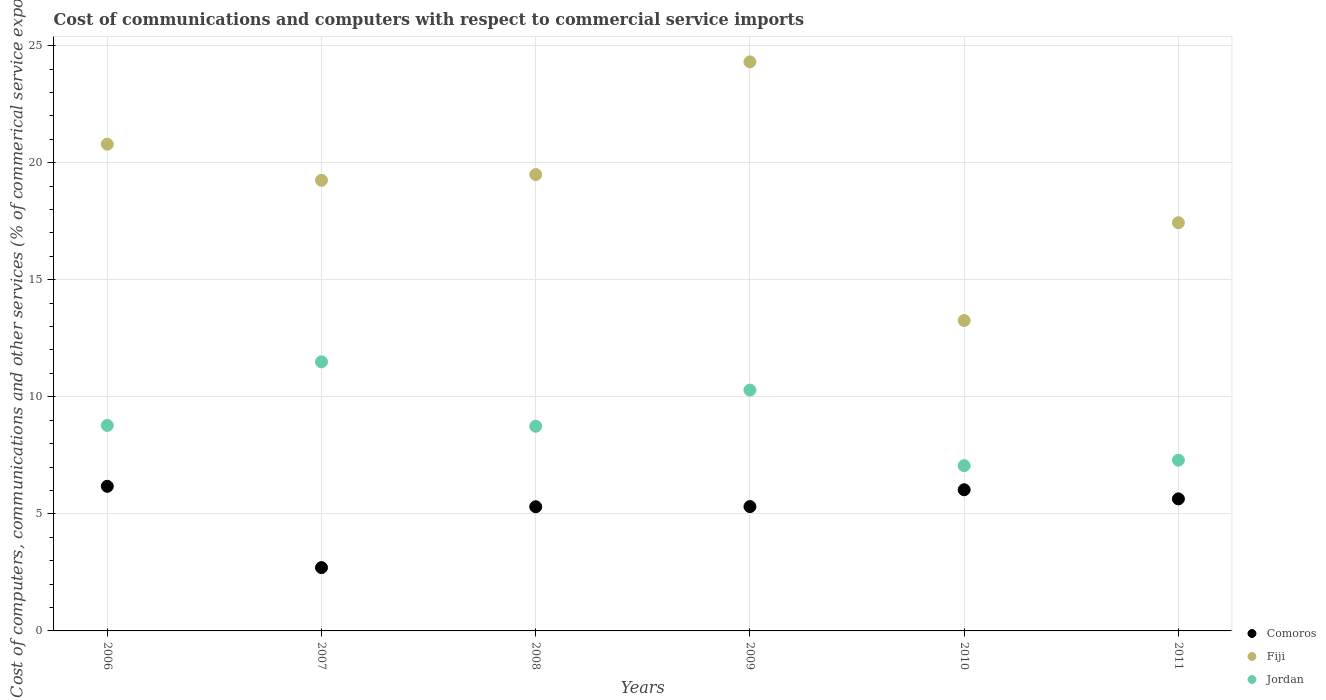How many different coloured dotlines are there?
Provide a succinct answer. 3. What is the cost of communications and computers in Comoros in 2010?
Provide a short and direct response. 6.03. Across all years, what is the maximum cost of communications and computers in Comoros?
Your answer should be compact. 6.18. Across all years, what is the minimum cost of communications and computers in Comoros?
Your answer should be very brief. 2.71. In which year was the cost of communications and computers in Fiji maximum?
Your response must be concise. 2009. In which year was the cost of communications and computers in Comoros minimum?
Make the answer very short. 2007. What is the total cost of communications and computers in Comoros in the graph?
Your response must be concise. 31.17. What is the difference between the cost of communications and computers in Fiji in 2008 and that in 2011?
Ensure brevity in your answer.  2.06. What is the difference between the cost of communications and computers in Jordan in 2011 and the cost of communications and computers in Fiji in 2008?
Give a very brief answer. -12.2. What is the average cost of communications and computers in Fiji per year?
Provide a short and direct response. 19.09. In the year 2007, what is the difference between the cost of communications and computers in Comoros and cost of communications and computers in Fiji?
Ensure brevity in your answer.  -16.54. In how many years, is the cost of communications and computers in Comoros greater than 5 %?
Offer a terse response. 5. What is the ratio of the cost of communications and computers in Comoros in 2007 to that in 2010?
Your answer should be compact. 0.45. Is the cost of communications and computers in Comoros in 2007 less than that in 2009?
Offer a very short reply. Yes. What is the difference between the highest and the second highest cost of communications and computers in Jordan?
Provide a succinct answer. 1.21. What is the difference between the highest and the lowest cost of communications and computers in Fiji?
Ensure brevity in your answer.  11.05. Is the sum of the cost of communications and computers in Jordan in 2008 and 2010 greater than the maximum cost of communications and computers in Comoros across all years?
Ensure brevity in your answer.  Yes. Is it the case that in every year, the sum of the cost of communications and computers in Comoros and cost of communications and computers in Fiji  is greater than the cost of communications and computers in Jordan?
Offer a terse response. Yes. Is the cost of communications and computers in Jordan strictly greater than the cost of communications and computers in Comoros over the years?
Offer a very short reply. Yes. How many dotlines are there?
Give a very brief answer. 3. Are the values on the major ticks of Y-axis written in scientific E-notation?
Offer a terse response. No. Where does the legend appear in the graph?
Ensure brevity in your answer.  Bottom right. What is the title of the graph?
Your answer should be very brief. Cost of communications and computers with respect to commercial service imports. Does "Tuvalu" appear as one of the legend labels in the graph?
Give a very brief answer. No. What is the label or title of the X-axis?
Keep it short and to the point. Years. What is the label or title of the Y-axis?
Keep it short and to the point. Cost of computers, communications and other services (% of commerical service exports). What is the Cost of computers, communications and other services (% of commerical service exports) in Comoros in 2006?
Keep it short and to the point. 6.18. What is the Cost of computers, communications and other services (% of commerical service exports) of Fiji in 2006?
Your answer should be compact. 20.79. What is the Cost of computers, communications and other services (% of commerical service exports) in Jordan in 2006?
Ensure brevity in your answer.  8.78. What is the Cost of computers, communications and other services (% of commerical service exports) of Comoros in 2007?
Provide a succinct answer. 2.71. What is the Cost of computers, communications and other services (% of commerical service exports) in Fiji in 2007?
Offer a very short reply. 19.25. What is the Cost of computers, communications and other services (% of commerical service exports) of Jordan in 2007?
Provide a short and direct response. 11.49. What is the Cost of computers, communications and other services (% of commerical service exports) in Comoros in 2008?
Your answer should be compact. 5.3. What is the Cost of computers, communications and other services (% of commerical service exports) in Fiji in 2008?
Offer a very short reply. 19.49. What is the Cost of computers, communications and other services (% of commerical service exports) of Jordan in 2008?
Give a very brief answer. 8.74. What is the Cost of computers, communications and other services (% of commerical service exports) in Comoros in 2009?
Your response must be concise. 5.31. What is the Cost of computers, communications and other services (% of commerical service exports) in Fiji in 2009?
Make the answer very short. 24.31. What is the Cost of computers, communications and other services (% of commerical service exports) in Jordan in 2009?
Provide a succinct answer. 10.29. What is the Cost of computers, communications and other services (% of commerical service exports) in Comoros in 2010?
Keep it short and to the point. 6.03. What is the Cost of computers, communications and other services (% of commerical service exports) of Fiji in 2010?
Offer a very short reply. 13.26. What is the Cost of computers, communications and other services (% of commerical service exports) in Jordan in 2010?
Provide a short and direct response. 7.06. What is the Cost of computers, communications and other services (% of commerical service exports) of Comoros in 2011?
Your answer should be compact. 5.64. What is the Cost of computers, communications and other services (% of commerical service exports) in Fiji in 2011?
Provide a succinct answer. 17.43. What is the Cost of computers, communications and other services (% of commerical service exports) of Jordan in 2011?
Offer a very short reply. 7.29. Across all years, what is the maximum Cost of computers, communications and other services (% of commerical service exports) in Comoros?
Give a very brief answer. 6.18. Across all years, what is the maximum Cost of computers, communications and other services (% of commerical service exports) in Fiji?
Your answer should be compact. 24.31. Across all years, what is the maximum Cost of computers, communications and other services (% of commerical service exports) in Jordan?
Your answer should be very brief. 11.49. Across all years, what is the minimum Cost of computers, communications and other services (% of commerical service exports) in Comoros?
Offer a very short reply. 2.71. Across all years, what is the minimum Cost of computers, communications and other services (% of commerical service exports) in Fiji?
Keep it short and to the point. 13.26. Across all years, what is the minimum Cost of computers, communications and other services (% of commerical service exports) in Jordan?
Your answer should be very brief. 7.06. What is the total Cost of computers, communications and other services (% of commerical service exports) of Comoros in the graph?
Make the answer very short. 31.17. What is the total Cost of computers, communications and other services (% of commerical service exports) in Fiji in the graph?
Your answer should be compact. 114.53. What is the total Cost of computers, communications and other services (% of commerical service exports) in Jordan in the graph?
Provide a succinct answer. 53.65. What is the difference between the Cost of computers, communications and other services (% of commerical service exports) of Comoros in 2006 and that in 2007?
Your answer should be compact. 3.47. What is the difference between the Cost of computers, communications and other services (% of commerical service exports) in Fiji in 2006 and that in 2007?
Offer a terse response. 1.54. What is the difference between the Cost of computers, communications and other services (% of commerical service exports) of Jordan in 2006 and that in 2007?
Provide a short and direct response. -2.72. What is the difference between the Cost of computers, communications and other services (% of commerical service exports) in Comoros in 2006 and that in 2008?
Your answer should be very brief. 0.87. What is the difference between the Cost of computers, communications and other services (% of commerical service exports) of Fiji in 2006 and that in 2008?
Keep it short and to the point. 1.3. What is the difference between the Cost of computers, communications and other services (% of commerical service exports) in Jordan in 2006 and that in 2008?
Provide a succinct answer. 0.03. What is the difference between the Cost of computers, communications and other services (% of commerical service exports) in Comoros in 2006 and that in 2009?
Ensure brevity in your answer.  0.87. What is the difference between the Cost of computers, communications and other services (% of commerical service exports) in Fiji in 2006 and that in 2009?
Make the answer very short. -3.52. What is the difference between the Cost of computers, communications and other services (% of commerical service exports) in Jordan in 2006 and that in 2009?
Keep it short and to the point. -1.51. What is the difference between the Cost of computers, communications and other services (% of commerical service exports) of Comoros in 2006 and that in 2010?
Keep it short and to the point. 0.15. What is the difference between the Cost of computers, communications and other services (% of commerical service exports) of Fiji in 2006 and that in 2010?
Your answer should be very brief. 7.53. What is the difference between the Cost of computers, communications and other services (% of commerical service exports) of Jordan in 2006 and that in 2010?
Offer a terse response. 1.72. What is the difference between the Cost of computers, communications and other services (% of commerical service exports) of Comoros in 2006 and that in 2011?
Your answer should be compact. 0.54. What is the difference between the Cost of computers, communications and other services (% of commerical service exports) in Fiji in 2006 and that in 2011?
Offer a terse response. 3.35. What is the difference between the Cost of computers, communications and other services (% of commerical service exports) of Jordan in 2006 and that in 2011?
Offer a very short reply. 1.48. What is the difference between the Cost of computers, communications and other services (% of commerical service exports) in Comoros in 2007 and that in 2008?
Your answer should be compact. -2.6. What is the difference between the Cost of computers, communications and other services (% of commerical service exports) in Fiji in 2007 and that in 2008?
Offer a terse response. -0.24. What is the difference between the Cost of computers, communications and other services (% of commerical service exports) in Jordan in 2007 and that in 2008?
Ensure brevity in your answer.  2.75. What is the difference between the Cost of computers, communications and other services (% of commerical service exports) in Comoros in 2007 and that in 2009?
Your response must be concise. -2.6. What is the difference between the Cost of computers, communications and other services (% of commerical service exports) in Fiji in 2007 and that in 2009?
Your answer should be very brief. -5.06. What is the difference between the Cost of computers, communications and other services (% of commerical service exports) of Jordan in 2007 and that in 2009?
Provide a succinct answer. 1.21. What is the difference between the Cost of computers, communications and other services (% of commerical service exports) of Comoros in 2007 and that in 2010?
Provide a short and direct response. -3.32. What is the difference between the Cost of computers, communications and other services (% of commerical service exports) in Fiji in 2007 and that in 2010?
Your answer should be compact. 5.99. What is the difference between the Cost of computers, communications and other services (% of commerical service exports) in Jordan in 2007 and that in 2010?
Your answer should be very brief. 4.44. What is the difference between the Cost of computers, communications and other services (% of commerical service exports) in Comoros in 2007 and that in 2011?
Your answer should be compact. -2.93. What is the difference between the Cost of computers, communications and other services (% of commerical service exports) in Fiji in 2007 and that in 2011?
Make the answer very short. 1.81. What is the difference between the Cost of computers, communications and other services (% of commerical service exports) in Jordan in 2007 and that in 2011?
Provide a succinct answer. 4.2. What is the difference between the Cost of computers, communications and other services (% of commerical service exports) in Comoros in 2008 and that in 2009?
Offer a very short reply. -0.01. What is the difference between the Cost of computers, communications and other services (% of commerical service exports) in Fiji in 2008 and that in 2009?
Provide a short and direct response. -4.82. What is the difference between the Cost of computers, communications and other services (% of commerical service exports) in Jordan in 2008 and that in 2009?
Your answer should be very brief. -1.54. What is the difference between the Cost of computers, communications and other services (% of commerical service exports) of Comoros in 2008 and that in 2010?
Your answer should be compact. -0.73. What is the difference between the Cost of computers, communications and other services (% of commerical service exports) of Fiji in 2008 and that in 2010?
Your answer should be very brief. 6.23. What is the difference between the Cost of computers, communications and other services (% of commerical service exports) in Jordan in 2008 and that in 2010?
Your answer should be compact. 1.68. What is the difference between the Cost of computers, communications and other services (% of commerical service exports) in Comoros in 2008 and that in 2011?
Ensure brevity in your answer.  -0.34. What is the difference between the Cost of computers, communications and other services (% of commerical service exports) in Fiji in 2008 and that in 2011?
Make the answer very short. 2.06. What is the difference between the Cost of computers, communications and other services (% of commerical service exports) in Jordan in 2008 and that in 2011?
Your response must be concise. 1.45. What is the difference between the Cost of computers, communications and other services (% of commerical service exports) of Comoros in 2009 and that in 2010?
Your answer should be very brief. -0.72. What is the difference between the Cost of computers, communications and other services (% of commerical service exports) in Fiji in 2009 and that in 2010?
Make the answer very short. 11.05. What is the difference between the Cost of computers, communications and other services (% of commerical service exports) of Jordan in 2009 and that in 2010?
Provide a short and direct response. 3.23. What is the difference between the Cost of computers, communications and other services (% of commerical service exports) in Comoros in 2009 and that in 2011?
Ensure brevity in your answer.  -0.33. What is the difference between the Cost of computers, communications and other services (% of commerical service exports) in Fiji in 2009 and that in 2011?
Keep it short and to the point. 6.87. What is the difference between the Cost of computers, communications and other services (% of commerical service exports) in Jordan in 2009 and that in 2011?
Your answer should be compact. 2.99. What is the difference between the Cost of computers, communications and other services (% of commerical service exports) in Comoros in 2010 and that in 2011?
Offer a terse response. 0.39. What is the difference between the Cost of computers, communications and other services (% of commerical service exports) in Fiji in 2010 and that in 2011?
Your response must be concise. -4.18. What is the difference between the Cost of computers, communications and other services (% of commerical service exports) of Jordan in 2010 and that in 2011?
Provide a short and direct response. -0.23. What is the difference between the Cost of computers, communications and other services (% of commerical service exports) in Comoros in 2006 and the Cost of computers, communications and other services (% of commerical service exports) in Fiji in 2007?
Provide a short and direct response. -13.07. What is the difference between the Cost of computers, communications and other services (% of commerical service exports) in Comoros in 2006 and the Cost of computers, communications and other services (% of commerical service exports) in Jordan in 2007?
Offer a very short reply. -5.32. What is the difference between the Cost of computers, communications and other services (% of commerical service exports) of Fiji in 2006 and the Cost of computers, communications and other services (% of commerical service exports) of Jordan in 2007?
Your answer should be very brief. 9.3. What is the difference between the Cost of computers, communications and other services (% of commerical service exports) of Comoros in 2006 and the Cost of computers, communications and other services (% of commerical service exports) of Fiji in 2008?
Give a very brief answer. -13.31. What is the difference between the Cost of computers, communications and other services (% of commerical service exports) in Comoros in 2006 and the Cost of computers, communications and other services (% of commerical service exports) in Jordan in 2008?
Offer a very short reply. -2.57. What is the difference between the Cost of computers, communications and other services (% of commerical service exports) in Fiji in 2006 and the Cost of computers, communications and other services (% of commerical service exports) in Jordan in 2008?
Your answer should be compact. 12.05. What is the difference between the Cost of computers, communications and other services (% of commerical service exports) in Comoros in 2006 and the Cost of computers, communications and other services (% of commerical service exports) in Fiji in 2009?
Keep it short and to the point. -18.13. What is the difference between the Cost of computers, communications and other services (% of commerical service exports) of Comoros in 2006 and the Cost of computers, communications and other services (% of commerical service exports) of Jordan in 2009?
Make the answer very short. -4.11. What is the difference between the Cost of computers, communications and other services (% of commerical service exports) in Fiji in 2006 and the Cost of computers, communications and other services (% of commerical service exports) in Jordan in 2009?
Offer a terse response. 10.5. What is the difference between the Cost of computers, communications and other services (% of commerical service exports) of Comoros in 2006 and the Cost of computers, communications and other services (% of commerical service exports) of Fiji in 2010?
Your response must be concise. -7.08. What is the difference between the Cost of computers, communications and other services (% of commerical service exports) of Comoros in 2006 and the Cost of computers, communications and other services (% of commerical service exports) of Jordan in 2010?
Your response must be concise. -0.88. What is the difference between the Cost of computers, communications and other services (% of commerical service exports) in Fiji in 2006 and the Cost of computers, communications and other services (% of commerical service exports) in Jordan in 2010?
Give a very brief answer. 13.73. What is the difference between the Cost of computers, communications and other services (% of commerical service exports) in Comoros in 2006 and the Cost of computers, communications and other services (% of commerical service exports) in Fiji in 2011?
Your answer should be compact. -11.26. What is the difference between the Cost of computers, communications and other services (% of commerical service exports) of Comoros in 2006 and the Cost of computers, communications and other services (% of commerical service exports) of Jordan in 2011?
Your answer should be compact. -1.12. What is the difference between the Cost of computers, communications and other services (% of commerical service exports) in Fiji in 2006 and the Cost of computers, communications and other services (% of commerical service exports) in Jordan in 2011?
Your answer should be very brief. 13.5. What is the difference between the Cost of computers, communications and other services (% of commerical service exports) in Comoros in 2007 and the Cost of computers, communications and other services (% of commerical service exports) in Fiji in 2008?
Keep it short and to the point. -16.79. What is the difference between the Cost of computers, communications and other services (% of commerical service exports) in Comoros in 2007 and the Cost of computers, communications and other services (% of commerical service exports) in Jordan in 2008?
Your answer should be very brief. -6.04. What is the difference between the Cost of computers, communications and other services (% of commerical service exports) in Fiji in 2007 and the Cost of computers, communications and other services (% of commerical service exports) in Jordan in 2008?
Ensure brevity in your answer.  10.51. What is the difference between the Cost of computers, communications and other services (% of commerical service exports) of Comoros in 2007 and the Cost of computers, communications and other services (% of commerical service exports) of Fiji in 2009?
Give a very brief answer. -21.6. What is the difference between the Cost of computers, communications and other services (% of commerical service exports) in Comoros in 2007 and the Cost of computers, communications and other services (% of commerical service exports) in Jordan in 2009?
Ensure brevity in your answer.  -7.58. What is the difference between the Cost of computers, communications and other services (% of commerical service exports) of Fiji in 2007 and the Cost of computers, communications and other services (% of commerical service exports) of Jordan in 2009?
Your response must be concise. 8.96. What is the difference between the Cost of computers, communications and other services (% of commerical service exports) of Comoros in 2007 and the Cost of computers, communications and other services (% of commerical service exports) of Fiji in 2010?
Offer a very short reply. -10.55. What is the difference between the Cost of computers, communications and other services (% of commerical service exports) in Comoros in 2007 and the Cost of computers, communications and other services (% of commerical service exports) in Jordan in 2010?
Make the answer very short. -4.35. What is the difference between the Cost of computers, communications and other services (% of commerical service exports) in Fiji in 2007 and the Cost of computers, communications and other services (% of commerical service exports) in Jordan in 2010?
Provide a short and direct response. 12.19. What is the difference between the Cost of computers, communications and other services (% of commerical service exports) in Comoros in 2007 and the Cost of computers, communications and other services (% of commerical service exports) in Fiji in 2011?
Provide a short and direct response. -14.73. What is the difference between the Cost of computers, communications and other services (% of commerical service exports) in Comoros in 2007 and the Cost of computers, communications and other services (% of commerical service exports) in Jordan in 2011?
Give a very brief answer. -4.59. What is the difference between the Cost of computers, communications and other services (% of commerical service exports) in Fiji in 2007 and the Cost of computers, communications and other services (% of commerical service exports) in Jordan in 2011?
Your answer should be compact. 11.96. What is the difference between the Cost of computers, communications and other services (% of commerical service exports) in Comoros in 2008 and the Cost of computers, communications and other services (% of commerical service exports) in Fiji in 2009?
Keep it short and to the point. -19. What is the difference between the Cost of computers, communications and other services (% of commerical service exports) of Comoros in 2008 and the Cost of computers, communications and other services (% of commerical service exports) of Jordan in 2009?
Your response must be concise. -4.98. What is the difference between the Cost of computers, communications and other services (% of commerical service exports) of Fiji in 2008 and the Cost of computers, communications and other services (% of commerical service exports) of Jordan in 2009?
Provide a short and direct response. 9.21. What is the difference between the Cost of computers, communications and other services (% of commerical service exports) of Comoros in 2008 and the Cost of computers, communications and other services (% of commerical service exports) of Fiji in 2010?
Ensure brevity in your answer.  -7.95. What is the difference between the Cost of computers, communications and other services (% of commerical service exports) in Comoros in 2008 and the Cost of computers, communications and other services (% of commerical service exports) in Jordan in 2010?
Ensure brevity in your answer.  -1.75. What is the difference between the Cost of computers, communications and other services (% of commerical service exports) in Fiji in 2008 and the Cost of computers, communications and other services (% of commerical service exports) in Jordan in 2010?
Keep it short and to the point. 12.43. What is the difference between the Cost of computers, communications and other services (% of commerical service exports) in Comoros in 2008 and the Cost of computers, communications and other services (% of commerical service exports) in Fiji in 2011?
Ensure brevity in your answer.  -12.13. What is the difference between the Cost of computers, communications and other services (% of commerical service exports) in Comoros in 2008 and the Cost of computers, communications and other services (% of commerical service exports) in Jordan in 2011?
Make the answer very short. -1.99. What is the difference between the Cost of computers, communications and other services (% of commerical service exports) in Fiji in 2008 and the Cost of computers, communications and other services (% of commerical service exports) in Jordan in 2011?
Offer a very short reply. 12.2. What is the difference between the Cost of computers, communications and other services (% of commerical service exports) of Comoros in 2009 and the Cost of computers, communications and other services (% of commerical service exports) of Fiji in 2010?
Give a very brief answer. -7.95. What is the difference between the Cost of computers, communications and other services (% of commerical service exports) in Comoros in 2009 and the Cost of computers, communications and other services (% of commerical service exports) in Jordan in 2010?
Offer a terse response. -1.75. What is the difference between the Cost of computers, communications and other services (% of commerical service exports) of Fiji in 2009 and the Cost of computers, communications and other services (% of commerical service exports) of Jordan in 2010?
Ensure brevity in your answer.  17.25. What is the difference between the Cost of computers, communications and other services (% of commerical service exports) in Comoros in 2009 and the Cost of computers, communications and other services (% of commerical service exports) in Fiji in 2011?
Ensure brevity in your answer.  -12.12. What is the difference between the Cost of computers, communications and other services (% of commerical service exports) of Comoros in 2009 and the Cost of computers, communications and other services (% of commerical service exports) of Jordan in 2011?
Make the answer very short. -1.98. What is the difference between the Cost of computers, communications and other services (% of commerical service exports) in Fiji in 2009 and the Cost of computers, communications and other services (% of commerical service exports) in Jordan in 2011?
Your answer should be very brief. 17.01. What is the difference between the Cost of computers, communications and other services (% of commerical service exports) in Comoros in 2010 and the Cost of computers, communications and other services (% of commerical service exports) in Fiji in 2011?
Your response must be concise. -11.4. What is the difference between the Cost of computers, communications and other services (% of commerical service exports) of Comoros in 2010 and the Cost of computers, communications and other services (% of commerical service exports) of Jordan in 2011?
Keep it short and to the point. -1.26. What is the difference between the Cost of computers, communications and other services (% of commerical service exports) in Fiji in 2010 and the Cost of computers, communications and other services (% of commerical service exports) in Jordan in 2011?
Offer a terse response. 5.96. What is the average Cost of computers, communications and other services (% of commerical service exports) of Comoros per year?
Provide a succinct answer. 5.19. What is the average Cost of computers, communications and other services (% of commerical service exports) of Fiji per year?
Your response must be concise. 19.09. What is the average Cost of computers, communications and other services (% of commerical service exports) of Jordan per year?
Provide a succinct answer. 8.94. In the year 2006, what is the difference between the Cost of computers, communications and other services (% of commerical service exports) of Comoros and Cost of computers, communications and other services (% of commerical service exports) of Fiji?
Give a very brief answer. -14.61. In the year 2006, what is the difference between the Cost of computers, communications and other services (% of commerical service exports) of Comoros and Cost of computers, communications and other services (% of commerical service exports) of Jordan?
Keep it short and to the point. -2.6. In the year 2006, what is the difference between the Cost of computers, communications and other services (% of commerical service exports) of Fiji and Cost of computers, communications and other services (% of commerical service exports) of Jordan?
Your answer should be very brief. 12.01. In the year 2007, what is the difference between the Cost of computers, communications and other services (% of commerical service exports) in Comoros and Cost of computers, communications and other services (% of commerical service exports) in Fiji?
Offer a very short reply. -16.54. In the year 2007, what is the difference between the Cost of computers, communications and other services (% of commerical service exports) of Comoros and Cost of computers, communications and other services (% of commerical service exports) of Jordan?
Offer a terse response. -8.79. In the year 2007, what is the difference between the Cost of computers, communications and other services (% of commerical service exports) of Fiji and Cost of computers, communications and other services (% of commerical service exports) of Jordan?
Keep it short and to the point. 7.75. In the year 2008, what is the difference between the Cost of computers, communications and other services (% of commerical service exports) in Comoros and Cost of computers, communications and other services (% of commerical service exports) in Fiji?
Offer a very short reply. -14.19. In the year 2008, what is the difference between the Cost of computers, communications and other services (% of commerical service exports) in Comoros and Cost of computers, communications and other services (% of commerical service exports) in Jordan?
Provide a succinct answer. -3.44. In the year 2008, what is the difference between the Cost of computers, communications and other services (% of commerical service exports) of Fiji and Cost of computers, communications and other services (% of commerical service exports) of Jordan?
Offer a very short reply. 10.75. In the year 2009, what is the difference between the Cost of computers, communications and other services (% of commerical service exports) of Comoros and Cost of computers, communications and other services (% of commerical service exports) of Fiji?
Give a very brief answer. -19. In the year 2009, what is the difference between the Cost of computers, communications and other services (% of commerical service exports) in Comoros and Cost of computers, communications and other services (% of commerical service exports) in Jordan?
Your response must be concise. -4.98. In the year 2009, what is the difference between the Cost of computers, communications and other services (% of commerical service exports) in Fiji and Cost of computers, communications and other services (% of commerical service exports) in Jordan?
Provide a short and direct response. 14.02. In the year 2010, what is the difference between the Cost of computers, communications and other services (% of commerical service exports) of Comoros and Cost of computers, communications and other services (% of commerical service exports) of Fiji?
Provide a short and direct response. -7.23. In the year 2010, what is the difference between the Cost of computers, communications and other services (% of commerical service exports) in Comoros and Cost of computers, communications and other services (% of commerical service exports) in Jordan?
Make the answer very short. -1.03. In the year 2010, what is the difference between the Cost of computers, communications and other services (% of commerical service exports) in Fiji and Cost of computers, communications and other services (% of commerical service exports) in Jordan?
Provide a short and direct response. 6.2. In the year 2011, what is the difference between the Cost of computers, communications and other services (% of commerical service exports) in Comoros and Cost of computers, communications and other services (% of commerical service exports) in Fiji?
Your answer should be very brief. -11.79. In the year 2011, what is the difference between the Cost of computers, communications and other services (% of commerical service exports) in Comoros and Cost of computers, communications and other services (% of commerical service exports) in Jordan?
Keep it short and to the point. -1.65. In the year 2011, what is the difference between the Cost of computers, communications and other services (% of commerical service exports) in Fiji and Cost of computers, communications and other services (% of commerical service exports) in Jordan?
Ensure brevity in your answer.  10.14. What is the ratio of the Cost of computers, communications and other services (% of commerical service exports) of Comoros in 2006 to that in 2007?
Give a very brief answer. 2.28. What is the ratio of the Cost of computers, communications and other services (% of commerical service exports) in Fiji in 2006 to that in 2007?
Provide a succinct answer. 1.08. What is the ratio of the Cost of computers, communications and other services (% of commerical service exports) in Jordan in 2006 to that in 2007?
Make the answer very short. 0.76. What is the ratio of the Cost of computers, communications and other services (% of commerical service exports) in Comoros in 2006 to that in 2008?
Your answer should be compact. 1.16. What is the ratio of the Cost of computers, communications and other services (% of commerical service exports) of Fiji in 2006 to that in 2008?
Your answer should be very brief. 1.07. What is the ratio of the Cost of computers, communications and other services (% of commerical service exports) of Comoros in 2006 to that in 2009?
Offer a terse response. 1.16. What is the ratio of the Cost of computers, communications and other services (% of commerical service exports) of Fiji in 2006 to that in 2009?
Offer a very short reply. 0.86. What is the ratio of the Cost of computers, communications and other services (% of commerical service exports) of Jordan in 2006 to that in 2009?
Keep it short and to the point. 0.85. What is the ratio of the Cost of computers, communications and other services (% of commerical service exports) in Comoros in 2006 to that in 2010?
Your response must be concise. 1.02. What is the ratio of the Cost of computers, communications and other services (% of commerical service exports) of Fiji in 2006 to that in 2010?
Provide a succinct answer. 1.57. What is the ratio of the Cost of computers, communications and other services (% of commerical service exports) in Jordan in 2006 to that in 2010?
Keep it short and to the point. 1.24. What is the ratio of the Cost of computers, communications and other services (% of commerical service exports) in Comoros in 2006 to that in 2011?
Make the answer very short. 1.1. What is the ratio of the Cost of computers, communications and other services (% of commerical service exports) of Fiji in 2006 to that in 2011?
Offer a very short reply. 1.19. What is the ratio of the Cost of computers, communications and other services (% of commerical service exports) in Jordan in 2006 to that in 2011?
Give a very brief answer. 1.2. What is the ratio of the Cost of computers, communications and other services (% of commerical service exports) of Comoros in 2007 to that in 2008?
Keep it short and to the point. 0.51. What is the ratio of the Cost of computers, communications and other services (% of commerical service exports) in Fiji in 2007 to that in 2008?
Provide a short and direct response. 0.99. What is the ratio of the Cost of computers, communications and other services (% of commerical service exports) in Jordan in 2007 to that in 2008?
Provide a succinct answer. 1.31. What is the ratio of the Cost of computers, communications and other services (% of commerical service exports) of Comoros in 2007 to that in 2009?
Your answer should be very brief. 0.51. What is the ratio of the Cost of computers, communications and other services (% of commerical service exports) of Fiji in 2007 to that in 2009?
Make the answer very short. 0.79. What is the ratio of the Cost of computers, communications and other services (% of commerical service exports) in Jordan in 2007 to that in 2009?
Give a very brief answer. 1.12. What is the ratio of the Cost of computers, communications and other services (% of commerical service exports) in Comoros in 2007 to that in 2010?
Offer a very short reply. 0.45. What is the ratio of the Cost of computers, communications and other services (% of commerical service exports) of Fiji in 2007 to that in 2010?
Provide a short and direct response. 1.45. What is the ratio of the Cost of computers, communications and other services (% of commerical service exports) in Jordan in 2007 to that in 2010?
Provide a succinct answer. 1.63. What is the ratio of the Cost of computers, communications and other services (% of commerical service exports) of Comoros in 2007 to that in 2011?
Make the answer very short. 0.48. What is the ratio of the Cost of computers, communications and other services (% of commerical service exports) of Fiji in 2007 to that in 2011?
Your response must be concise. 1.1. What is the ratio of the Cost of computers, communications and other services (% of commerical service exports) in Jordan in 2007 to that in 2011?
Offer a terse response. 1.58. What is the ratio of the Cost of computers, communications and other services (% of commerical service exports) in Fiji in 2008 to that in 2009?
Your response must be concise. 0.8. What is the ratio of the Cost of computers, communications and other services (% of commerical service exports) in Jordan in 2008 to that in 2009?
Provide a succinct answer. 0.85. What is the ratio of the Cost of computers, communications and other services (% of commerical service exports) in Comoros in 2008 to that in 2010?
Keep it short and to the point. 0.88. What is the ratio of the Cost of computers, communications and other services (% of commerical service exports) in Fiji in 2008 to that in 2010?
Ensure brevity in your answer.  1.47. What is the ratio of the Cost of computers, communications and other services (% of commerical service exports) of Jordan in 2008 to that in 2010?
Keep it short and to the point. 1.24. What is the ratio of the Cost of computers, communications and other services (% of commerical service exports) of Comoros in 2008 to that in 2011?
Your answer should be compact. 0.94. What is the ratio of the Cost of computers, communications and other services (% of commerical service exports) in Fiji in 2008 to that in 2011?
Provide a succinct answer. 1.12. What is the ratio of the Cost of computers, communications and other services (% of commerical service exports) of Jordan in 2008 to that in 2011?
Your answer should be compact. 1.2. What is the ratio of the Cost of computers, communications and other services (% of commerical service exports) in Comoros in 2009 to that in 2010?
Ensure brevity in your answer.  0.88. What is the ratio of the Cost of computers, communications and other services (% of commerical service exports) of Fiji in 2009 to that in 2010?
Ensure brevity in your answer.  1.83. What is the ratio of the Cost of computers, communications and other services (% of commerical service exports) in Jordan in 2009 to that in 2010?
Ensure brevity in your answer.  1.46. What is the ratio of the Cost of computers, communications and other services (% of commerical service exports) of Comoros in 2009 to that in 2011?
Make the answer very short. 0.94. What is the ratio of the Cost of computers, communications and other services (% of commerical service exports) of Fiji in 2009 to that in 2011?
Ensure brevity in your answer.  1.39. What is the ratio of the Cost of computers, communications and other services (% of commerical service exports) of Jordan in 2009 to that in 2011?
Your answer should be compact. 1.41. What is the ratio of the Cost of computers, communications and other services (% of commerical service exports) in Comoros in 2010 to that in 2011?
Provide a succinct answer. 1.07. What is the ratio of the Cost of computers, communications and other services (% of commerical service exports) in Fiji in 2010 to that in 2011?
Your response must be concise. 0.76. What is the ratio of the Cost of computers, communications and other services (% of commerical service exports) in Jordan in 2010 to that in 2011?
Offer a terse response. 0.97. What is the difference between the highest and the second highest Cost of computers, communications and other services (% of commerical service exports) in Comoros?
Make the answer very short. 0.15. What is the difference between the highest and the second highest Cost of computers, communications and other services (% of commerical service exports) in Fiji?
Your answer should be compact. 3.52. What is the difference between the highest and the second highest Cost of computers, communications and other services (% of commerical service exports) of Jordan?
Provide a succinct answer. 1.21. What is the difference between the highest and the lowest Cost of computers, communications and other services (% of commerical service exports) of Comoros?
Offer a very short reply. 3.47. What is the difference between the highest and the lowest Cost of computers, communications and other services (% of commerical service exports) in Fiji?
Make the answer very short. 11.05. What is the difference between the highest and the lowest Cost of computers, communications and other services (% of commerical service exports) in Jordan?
Your answer should be compact. 4.44. 